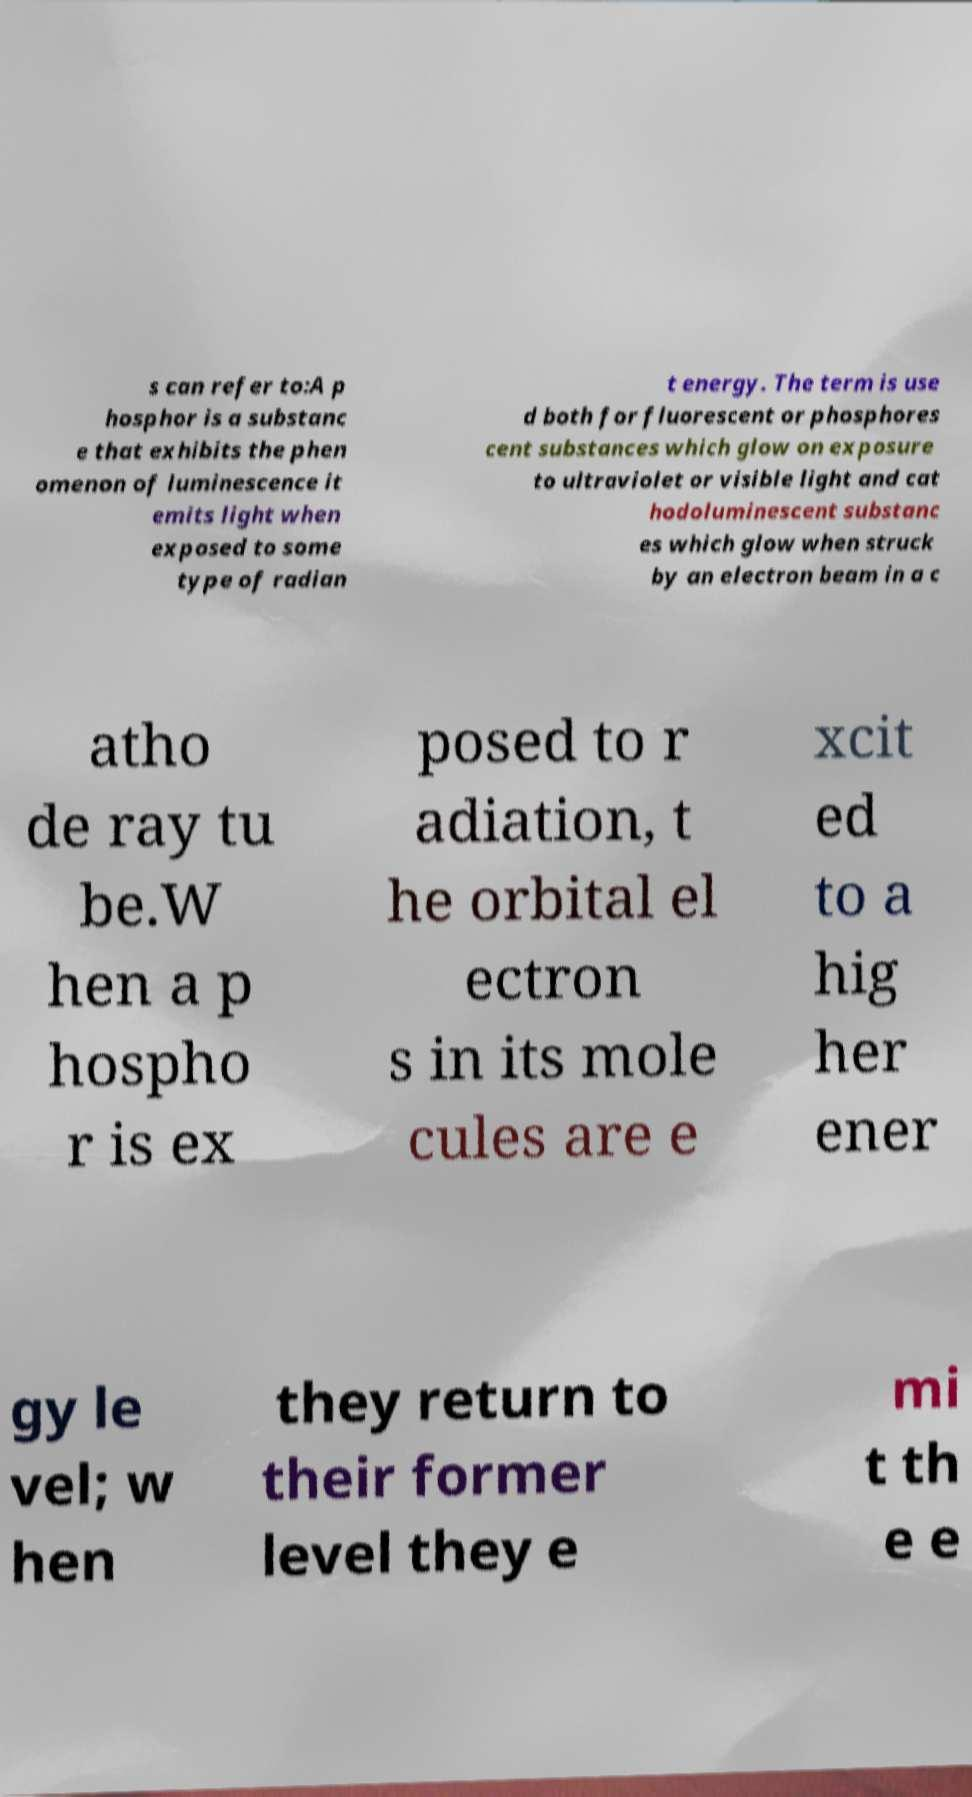What messages or text are displayed in this image? I need them in a readable, typed format. s can refer to:A p hosphor is a substanc e that exhibits the phen omenon of luminescence it emits light when exposed to some type of radian t energy. The term is use d both for fluorescent or phosphores cent substances which glow on exposure to ultraviolet or visible light and cat hodoluminescent substanc es which glow when struck by an electron beam in a c atho de ray tu be.W hen a p hospho r is ex posed to r adiation, t he orbital el ectron s in its mole cules are e xcit ed to a hig her ener gy le vel; w hen they return to their former level they e mi t th e e 